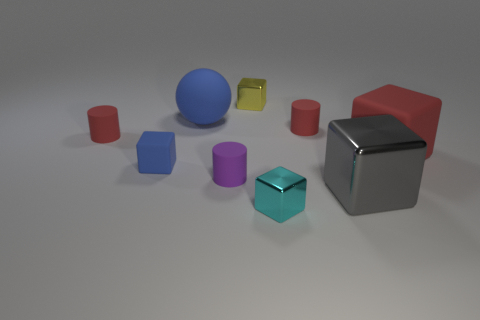There is a blue matte thing that is the same size as the gray metallic block; what shape is it?
Ensure brevity in your answer.  Sphere. Do the tiny cylinder to the right of the small yellow cube and the big matte block have the same color?
Your answer should be compact. Yes. What number of things are either things left of the small cyan block or purple objects?
Ensure brevity in your answer.  5. Are there more matte things behind the big rubber ball than red rubber cylinders that are right of the big gray metallic block?
Keep it short and to the point. No. Does the large gray cube have the same material as the small yellow cube?
Your answer should be very brief. Yes. There is a red object that is both on the left side of the gray shiny object and right of the small blue cube; what shape is it?
Your response must be concise. Cylinder. There is a cyan thing that is the same material as the large gray object; what shape is it?
Your answer should be very brief. Cube. Are there any red cylinders?
Give a very brief answer. Yes. There is a rubber cube that is right of the blue matte cube; is there a tiny matte cylinder that is behind it?
Offer a terse response. Yes. There is a tiny cyan object that is the same shape as the gray shiny thing; what is its material?
Your response must be concise. Metal. 